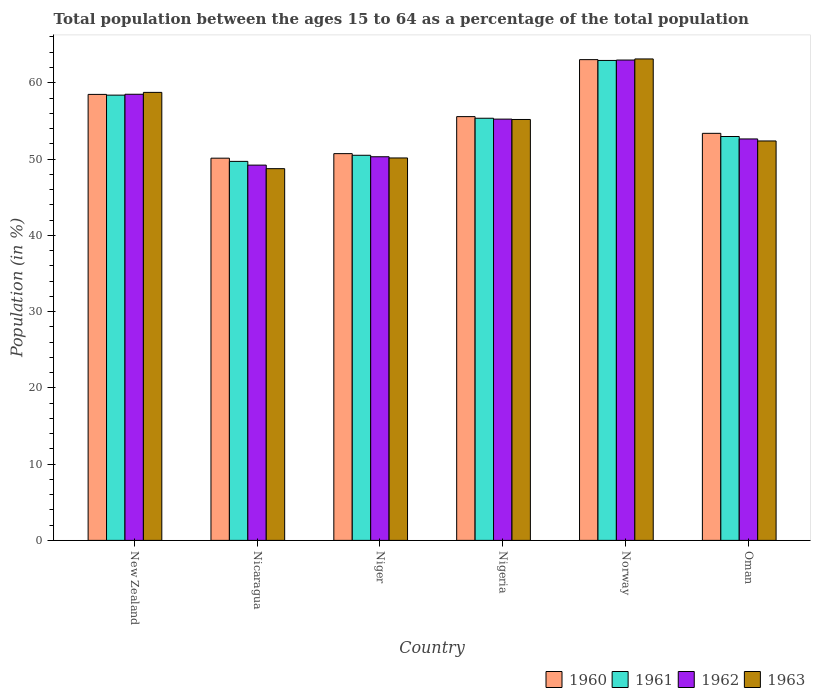How many different coloured bars are there?
Keep it short and to the point. 4. How many groups of bars are there?
Provide a succinct answer. 6. Are the number of bars per tick equal to the number of legend labels?
Your answer should be compact. Yes. How many bars are there on the 3rd tick from the left?
Keep it short and to the point. 4. What is the percentage of the population ages 15 to 64 in 1962 in Norway?
Your answer should be compact. 62.98. Across all countries, what is the maximum percentage of the population ages 15 to 64 in 1961?
Offer a very short reply. 62.92. Across all countries, what is the minimum percentage of the population ages 15 to 64 in 1963?
Provide a succinct answer. 48.74. In which country was the percentage of the population ages 15 to 64 in 1962 minimum?
Ensure brevity in your answer.  Nicaragua. What is the total percentage of the population ages 15 to 64 in 1960 in the graph?
Your answer should be compact. 331.26. What is the difference between the percentage of the population ages 15 to 64 in 1963 in Nicaragua and that in Norway?
Provide a short and direct response. -14.39. What is the difference between the percentage of the population ages 15 to 64 in 1962 in Oman and the percentage of the population ages 15 to 64 in 1960 in Nigeria?
Offer a terse response. -2.93. What is the average percentage of the population ages 15 to 64 in 1962 per country?
Give a very brief answer. 54.81. What is the difference between the percentage of the population ages 15 to 64 of/in 1962 and percentage of the population ages 15 to 64 of/in 1961 in Niger?
Your response must be concise. -0.2. What is the ratio of the percentage of the population ages 15 to 64 in 1961 in Nicaragua to that in Niger?
Offer a very short reply. 0.98. Is the percentage of the population ages 15 to 64 in 1961 in Niger less than that in Oman?
Provide a succinct answer. Yes. Is the difference between the percentage of the population ages 15 to 64 in 1962 in Nicaragua and Norway greater than the difference between the percentage of the population ages 15 to 64 in 1961 in Nicaragua and Norway?
Keep it short and to the point. No. What is the difference between the highest and the second highest percentage of the population ages 15 to 64 in 1962?
Provide a succinct answer. -4.49. What is the difference between the highest and the lowest percentage of the population ages 15 to 64 in 1960?
Offer a terse response. 12.92. What does the 2nd bar from the left in Nigeria represents?
Provide a short and direct response. 1961. What does the 2nd bar from the right in Oman represents?
Your answer should be compact. 1962. Are the values on the major ticks of Y-axis written in scientific E-notation?
Your answer should be very brief. No. Does the graph contain any zero values?
Provide a succinct answer. No. How many legend labels are there?
Your response must be concise. 4. How are the legend labels stacked?
Your answer should be compact. Horizontal. What is the title of the graph?
Provide a short and direct response. Total population between the ages 15 to 64 as a percentage of the total population. Does "2004" appear as one of the legend labels in the graph?
Offer a terse response. No. What is the Population (in %) in 1960 in New Zealand?
Provide a short and direct response. 58.47. What is the Population (in %) of 1961 in New Zealand?
Make the answer very short. 58.38. What is the Population (in %) of 1962 in New Zealand?
Make the answer very short. 58.49. What is the Population (in %) of 1963 in New Zealand?
Give a very brief answer. 58.74. What is the Population (in %) of 1960 in Nicaragua?
Provide a short and direct response. 50.11. What is the Population (in %) of 1961 in Nicaragua?
Ensure brevity in your answer.  49.69. What is the Population (in %) of 1962 in Nicaragua?
Your answer should be very brief. 49.2. What is the Population (in %) of 1963 in Nicaragua?
Keep it short and to the point. 48.74. What is the Population (in %) of 1960 in Niger?
Offer a terse response. 50.71. What is the Population (in %) in 1961 in Niger?
Your answer should be compact. 50.49. What is the Population (in %) of 1962 in Niger?
Offer a very short reply. 50.3. What is the Population (in %) in 1963 in Niger?
Keep it short and to the point. 50.14. What is the Population (in %) of 1960 in Nigeria?
Offer a very short reply. 55.56. What is the Population (in %) of 1961 in Nigeria?
Provide a succinct answer. 55.35. What is the Population (in %) in 1962 in Nigeria?
Keep it short and to the point. 55.23. What is the Population (in %) in 1963 in Nigeria?
Your answer should be compact. 55.19. What is the Population (in %) in 1960 in Norway?
Keep it short and to the point. 63.03. What is the Population (in %) in 1961 in Norway?
Provide a short and direct response. 62.92. What is the Population (in %) in 1962 in Norway?
Provide a short and direct response. 62.98. What is the Population (in %) of 1963 in Norway?
Make the answer very short. 63.12. What is the Population (in %) of 1960 in Oman?
Provide a short and direct response. 53.37. What is the Population (in %) of 1961 in Oman?
Your answer should be compact. 52.95. What is the Population (in %) in 1962 in Oman?
Make the answer very short. 52.63. What is the Population (in %) of 1963 in Oman?
Keep it short and to the point. 52.37. Across all countries, what is the maximum Population (in %) of 1960?
Provide a short and direct response. 63.03. Across all countries, what is the maximum Population (in %) in 1961?
Your answer should be very brief. 62.92. Across all countries, what is the maximum Population (in %) of 1962?
Your response must be concise. 62.98. Across all countries, what is the maximum Population (in %) in 1963?
Your response must be concise. 63.12. Across all countries, what is the minimum Population (in %) in 1960?
Offer a terse response. 50.11. Across all countries, what is the minimum Population (in %) of 1961?
Make the answer very short. 49.69. Across all countries, what is the minimum Population (in %) of 1962?
Offer a very short reply. 49.2. Across all countries, what is the minimum Population (in %) in 1963?
Keep it short and to the point. 48.74. What is the total Population (in %) of 1960 in the graph?
Your answer should be very brief. 331.26. What is the total Population (in %) of 1961 in the graph?
Your answer should be very brief. 329.79. What is the total Population (in %) in 1962 in the graph?
Your answer should be very brief. 328.84. What is the total Population (in %) of 1963 in the graph?
Provide a succinct answer. 328.3. What is the difference between the Population (in %) of 1960 in New Zealand and that in Nicaragua?
Your response must be concise. 8.36. What is the difference between the Population (in %) of 1961 in New Zealand and that in Nicaragua?
Your answer should be compact. 8.69. What is the difference between the Population (in %) of 1962 in New Zealand and that in Nicaragua?
Your answer should be compact. 9.29. What is the difference between the Population (in %) in 1963 in New Zealand and that in Nicaragua?
Ensure brevity in your answer.  10. What is the difference between the Population (in %) of 1960 in New Zealand and that in Niger?
Provide a short and direct response. 7.77. What is the difference between the Population (in %) in 1961 in New Zealand and that in Niger?
Provide a succinct answer. 7.88. What is the difference between the Population (in %) of 1962 in New Zealand and that in Niger?
Ensure brevity in your answer.  8.2. What is the difference between the Population (in %) of 1963 in New Zealand and that in Niger?
Make the answer very short. 8.6. What is the difference between the Population (in %) in 1960 in New Zealand and that in Nigeria?
Keep it short and to the point. 2.91. What is the difference between the Population (in %) in 1961 in New Zealand and that in Nigeria?
Your answer should be very brief. 3.03. What is the difference between the Population (in %) of 1962 in New Zealand and that in Nigeria?
Offer a very short reply. 3.26. What is the difference between the Population (in %) of 1963 in New Zealand and that in Nigeria?
Provide a short and direct response. 3.55. What is the difference between the Population (in %) in 1960 in New Zealand and that in Norway?
Keep it short and to the point. -4.56. What is the difference between the Population (in %) of 1961 in New Zealand and that in Norway?
Your answer should be compact. -4.55. What is the difference between the Population (in %) in 1962 in New Zealand and that in Norway?
Ensure brevity in your answer.  -4.49. What is the difference between the Population (in %) of 1963 in New Zealand and that in Norway?
Keep it short and to the point. -4.38. What is the difference between the Population (in %) in 1960 in New Zealand and that in Oman?
Your answer should be compact. 5.11. What is the difference between the Population (in %) in 1961 in New Zealand and that in Oman?
Your response must be concise. 5.42. What is the difference between the Population (in %) in 1962 in New Zealand and that in Oman?
Provide a short and direct response. 5.86. What is the difference between the Population (in %) in 1963 in New Zealand and that in Oman?
Your answer should be very brief. 6.37. What is the difference between the Population (in %) of 1960 in Nicaragua and that in Niger?
Give a very brief answer. -0.6. What is the difference between the Population (in %) in 1961 in Nicaragua and that in Niger?
Give a very brief answer. -0.8. What is the difference between the Population (in %) in 1962 in Nicaragua and that in Niger?
Make the answer very short. -1.1. What is the difference between the Population (in %) in 1963 in Nicaragua and that in Niger?
Provide a short and direct response. -1.41. What is the difference between the Population (in %) in 1960 in Nicaragua and that in Nigeria?
Make the answer very short. -5.45. What is the difference between the Population (in %) in 1961 in Nicaragua and that in Nigeria?
Give a very brief answer. -5.66. What is the difference between the Population (in %) of 1962 in Nicaragua and that in Nigeria?
Offer a terse response. -6.03. What is the difference between the Population (in %) in 1963 in Nicaragua and that in Nigeria?
Offer a very short reply. -6.45. What is the difference between the Population (in %) of 1960 in Nicaragua and that in Norway?
Offer a terse response. -12.92. What is the difference between the Population (in %) in 1961 in Nicaragua and that in Norway?
Make the answer very short. -13.23. What is the difference between the Population (in %) in 1962 in Nicaragua and that in Norway?
Your answer should be very brief. -13.78. What is the difference between the Population (in %) in 1963 in Nicaragua and that in Norway?
Your answer should be very brief. -14.39. What is the difference between the Population (in %) of 1960 in Nicaragua and that in Oman?
Your answer should be compact. -3.26. What is the difference between the Population (in %) of 1961 in Nicaragua and that in Oman?
Offer a terse response. -3.26. What is the difference between the Population (in %) of 1962 in Nicaragua and that in Oman?
Make the answer very short. -3.43. What is the difference between the Population (in %) in 1963 in Nicaragua and that in Oman?
Offer a very short reply. -3.63. What is the difference between the Population (in %) of 1960 in Niger and that in Nigeria?
Your answer should be compact. -4.85. What is the difference between the Population (in %) in 1961 in Niger and that in Nigeria?
Keep it short and to the point. -4.85. What is the difference between the Population (in %) of 1962 in Niger and that in Nigeria?
Provide a succinct answer. -4.93. What is the difference between the Population (in %) in 1963 in Niger and that in Nigeria?
Your response must be concise. -5.05. What is the difference between the Population (in %) in 1960 in Niger and that in Norway?
Your answer should be compact. -12.32. What is the difference between the Population (in %) in 1961 in Niger and that in Norway?
Make the answer very short. -12.43. What is the difference between the Population (in %) in 1962 in Niger and that in Norway?
Provide a short and direct response. -12.68. What is the difference between the Population (in %) of 1963 in Niger and that in Norway?
Keep it short and to the point. -12.98. What is the difference between the Population (in %) of 1960 in Niger and that in Oman?
Give a very brief answer. -2.66. What is the difference between the Population (in %) of 1961 in Niger and that in Oman?
Provide a succinct answer. -2.46. What is the difference between the Population (in %) in 1962 in Niger and that in Oman?
Offer a very short reply. -2.34. What is the difference between the Population (in %) of 1963 in Niger and that in Oman?
Make the answer very short. -2.23. What is the difference between the Population (in %) in 1960 in Nigeria and that in Norway?
Your response must be concise. -7.47. What is the difference between the Population (in %) in 1961 in Nigeria and that in Norway?
Offer a very short reply. -7.58. What is the difference between the Population (in %) of 1962 in Nigeria and that in Norway?
Your answer should be very brief. -7.75. What is the difference between the Population (in %) of 1963 in Nigeria and that in Norway?
Your answer should be very brief. -7.94. What is the difference between the Population (in %) of 1960 in Nigeria and that in Oman?
Ensure brevity in your answer.  2.19. What is the difference between the Population (in %) in 1961 in Nigeria and that in Oman?
Your response must be concise. 2.39. What is the difference between the Population (in %) in 1962 in Nigeria and that in Oman?
Offer a terse response. 2.6. What is the difference between the Population (in %) in 1963 in Nigeria and that in Oman?
Keep it short and to the point. 2.82. What is the difference between the Population (in %) in 1960 in Norway and that in Oman?
Your answer should be compact. 9.66. What is the difference between the Population (in %) of 1961 in Norway and that in Oman?
Offer a terse response. 9.97. What is the difference between the Population (in %) of 1962 in Norway and that in Oman?
Your response must be concise. 10.34. What is the difference between the Population (in %) of 1963 in Norway and that in Oman?
Offer a very short reply. 10.75. What is the difference between the Population (in %) in 1960 in New Zealand and the Population (in %) in 1961 in Nicaragua?
Offer a very short reply. 8.78. What is the difference between the Population (in %) in 1960 in New Zealand and the Population (in %) in 1962 in Nicaragua?
Your answer should be compact. 9.27. What is the difference between the Population (in %) of 1960 in New Zealand and the Population (in %) of 1963 in Nicaragua?
Ensure brevity in your answer.  9.74. What is the difference between the Population (in %) in 1961 in New Zealand and the Population (in %) in 1962 in Nicaragua?
Your answer should be compact. 9.18. What is the difference between the Population (in %) of 1961 in New Zealand and the Population (in %) of 1963 in Nicaragua?
Provide a succinct answer. 9.64. What is the difference between the Population (in %) in 1962 in New Zealand and the Population (in %) in 1963 in Nicaragua?
Provide a short and direct response. 9.76. What is the difference between the Population (in %) of 1960 in New Zealand and the Population (in %) of 1961 in Niger?
Give a very brief answer. 7.98. What is the difference between the Population (in %) in 1960 in New Zealand and the Population (in %) in 1962 in Niger?
Offer a very short reply. 8.18. What is the difference between the Population (in %) of 1960 in New Zealand and the Population (in %) of 1963 in Niger?
Make the answer very short. 8.33. What is the difference between the Population (in %) of 1961 in New Zealand and the Population (in %) of 1962 in Niger?
Keep it short and to the point. 8.08. What is the difference between the Population (in %) in 1961 in New Zealand and the Population (in %) in 1963 in Niger?
Your answer should be very brief. 8.24. What is the difference between the Population (in %) in 1962 in New Zealand and the Population (in %) in 1963 in Niger?
Your answer should be very brief. 8.35. What is the difference between the Population (in %) of 1960 in New Zealand and the Population (in %) of 1961 in Nigeria?
Your answer should be compact. 3.13. What is the difference between the Population (in %) in 1960 in New Zealand and the Population (in %) in 1962 in Nigeria?
Your answer should be very brief. 3.24. What is the difference between the Population (in %) of 1960 in New Zealand and the Population (in %) of 1963 in Nigeria?
Offer a very short reply. 3.29. What is the difference between the Population (in %) in 1961 in New Zealand and the Population (in %) in 1962 in Nigeria?
Give a very brief answer. 3.15. What is the difference between the Population (in %) in 1961 in New Zealand and the Population (in %) in 1963 in Nigeria?
Your response must be concise. 3.19. What is the difference between the Population (in %) of 1962 in New Zealand and the Population (in %) of 1963 in Nigeria?
Keep it short and to the point. 3.31. What is the difference between the Population (in %) in 1960 in New Zealand and the Population (in %) in 1961 in Norway?
Offer a very short reply. -4.45. What is the difference between the Population (in %) of 1960 in New Zealand and the Population (in %) of 1962 in Norway?
Your response must be concise. -4.5. What is the difference between the Population (in %) of 1960 in New Zealand and the Population (in %) of 1963 in Norway?
Your answer should be very brief. -4.65. What is the difference between the Population (in %) of 1961 in New Zealand and the Population (in %) of 1962 in Norway?
Ensure brevity in your answer.  -4.6. What is the difference between the Population (in %) of 1961 in New Zealand and the Population (in %) of 1963 in Norway?
Your answer should be compact. -4.74. What is the difference between the Population (in %) of 1962 in New Zealand and the Population (in %) of 1963 in Norway?
Give a very brief answer. -4.63. What is the difference between the Population (in %) in 1960 in New Zealand and the Population (in %) in 1961 in Oman?
Your response must be concise. 5.52. What is the difference between the Population (in %) of 1960 in New Zealand and the Population (in %) of 1962 in Oman?
Your answer should be very brief. 5.84. What is the difference between the Population (in %) of 1960 in New Zealand and the Population (in %) of 1963 in Oman?
Keep it short and to the point. 6.11. What is the difference between the Population (in %) in 1961 in New Zealand and the Population (in %) in 1962 in Oman?
Provide a short and direct response. 5.74. What is the difference between the Population (in %) of 1961 in New Zealand and the Population (in %) of 1963 in Oman?
Offer a very short reply. 6.01. What is the difference between the Population (in %) of 1962 in New Zealand and the Population (in %) of 1963 in Oman?
Your response must be concise. 6.12. What is the difference between the Population (in %) in 1960 in Nicaragua and the Population (in %) in 1961 in Niger?
Your answer should be very brief. -0.38. What is the difference between the Population (in %) of 1960 in Nicaragua and the Population (in %) of 1962 in Niger?
Your answer should be compact. -0.19. What is the difference between the Population (in %) in 1960 in Nicaragua and the Population (in %) in 1963 in Niger?
Keep it short and to the point. -0.03. What is the difference between the Population (in %) of 1961 in Nicaragua and the Population (in %) of 1962 in Niger?
Provide a succinct answer. -0.61. What is the difference between the Population (in %) in 1961 in Nicaragua and the Population (in %) in 1963 in Niger?
Offer a terse response. -0.45. What is the difference between the Population (in %) in 1962 in Nicaragua and the Population (in %) in 1963 in Niger?
Make the answer very short. -0.94. What is the difference between the Population (in %) of 1960 in Nicaragua and the Population (in %) of 1961 in Nigeria?
Ensure brevity in your answer.  -5.23. What is the difference between the Population (in %) in 1960 in Nicaragua and the Population (in %) in 1962 in Nigeria?
Keep it short and to the point. -5.12. What is the difference between the Population (in %) in 1960 in Nicaragua and the Population (in %) in 1963 in Nigeria?
Your answer should be compact. -5.07. What is the difference between the Population (in %) of 1961 in Nicaragua and the Population (in %) of 1962 in Nigeria?
Ensure brevity in your answer.  -5.54. What is the difference between the Population (in %) in 1961 in Nicaragua and the Population (in %) in 1963 in Nigeria?
Offer a very short reply. -5.5. What is the difference between the Population (in %) of 1962 in Nicaragua and the Population (in %) of 1963 in Nigeria?
Provide a succinct answer. -5.98. What is the difference between the Population (in %) in 1960 in Nicaragua and the Population (in %) in 1961 in Norway?
Offer a terse response. -12.81. What is the difference between the Population (in %) of 1960 in Nicaragua and the Population (in %) of 1962 in Norway?
Make the answer very short. -12.87. What is the difference between the Population (in %) in 1960 in Nicaragua and the Population (in %) in 1963 in Norway?
Offer a terse response. -13.01. What is the difference between the Population (in %) of 1961 in Nicaragua and the Population (in %) of 1962 in Norway?
Keep it short and to the point. -13.29. What is the difference between the Population (in %) of 1961 in Nicaragua and the Population (in %) of 1963 in Norway?
Your answer should be compact. -13.43. What is the difference between the Population (in %) in 1962 in Nicaragua and the Population (in %) in 1963 in Norway?
Provide a short and direct response. -13.92. What is the difference between the Population (in %) of 1960 in Nicaragua and the Population (in %) of 1961 in Oman?
Provide a succinct answer. -2.84. What is the difference between the Population (in %) of 1960 in Nicaragua and the Population (in %) of 1962 in Oman?
Provide a succinct answer. -2.52. What is the difference between the Population (in %) in 1960 in Nicaragua and the Population (in %) in 1963 in Oman?
Give a very brief answer. -2.26. What is the difference between the Population (in %) of 1961 in Nicaragua and the Population (in %) of 1962 in Oman?
Make the answer very short. -2.94. What is the difference between the Population (in %) of 1961 in Nicaragua and the Population (in %) of 1963 in Oman?
Offer a very short reply. -2.68. What is the difference between the Population (in %) in 1962 in Nicaragua and the Population (in %) in 1963 in Oman?
Give a very brief answer. -3.17. What is the difference between the Population (in %) in 1960 in Niger and the Population (in %) in 1961 in Nigeria?
Provide a short and direct response. -4.64. What is the difference between the Population (in %) in 1960 in Niger and the Population (in %) in 1962 in Nigeria?
Provide a succinct answer. -4.52. What is the difference between the Population (in %) of 1960 in Niger and the Population (in %) of 1963 in Nigeria?
Make the answer very short. -4.48. What is the difference between the Population (in %) of 1961 in Niger and the Population (in %) of 1962 in Nigeria?
Keep it short and to the point. -4.74. What is the difference between the Population (in %) of 1961 in Niger and the Population (in %) of 1963 in Nigeria?
Keep it short and to the point. -4.69. What is the difference between the Population (in %) in 1962 in Niger and the Population (in %) in 1963 in Nigeria?
Provide a short and direct response. -4.89. What is the difference between the Population (in %) of 1960 in Niger and the Population (in %) of 1961 in Norway?
Your response must be concise. -12.22. What is the difference between the Population (in %) in 1960 in Niger and the Population (in %) in 1962 in Norway?
Your response must be concise. -12.27. What is the difference between the Population (in %) of 1960 in Niger and the Population (in %) of 1963 in Norway?
Offer a terse response. -12.41. What is the difference between the Population (in %) of 1961 in Niger and the Population (in %) of 1962 in Norway?
Offer a terse response. -12.49. What is the difference between the Population (in %) of 1961 in Niger and the Population (in %) of 1963 in Norway?
Offer a very short reply. -12.63. What is the difference between the Population (in %) of 1962 in Niger and the Population (in %) of 1963 in Norway?
Your answer should be very brief. -12.82. What is the difference between the Population (in %) in 1960 in Niger and the Population (in %) in 1961 in Oman?
Your answer should be compact. -2.25. What is the difference between the Population (in %) in 1960 in Niger and the Population (in %) in 1962 in Oman?
Provide a succinct answer. -1.93. What is the difference between the Population (in %) of 1960 in Niger and the Population (in %) of 1963 in Oman?
Provide a succinct answer. -1.66. What is the difference between the Population (in %) of 1961 in Niger and the Population (in %) of 1962 in Oman?
Keep it short and to the point. -2.14. What is the difference between the Population (in %) of 1961 in Niger and the Population (in %) of 1963 in Oman?
Provide a succinct answer. -1.87. What is the difference between the Population (in %) of 1962 in Niger and the Population (in %) of 1963 in Oman?
Give a very brief answer. -2.07. What is the difference between the Population (in %) of 1960 in Nigeria and the Population (in %) of 1961 in Norway?
Provide a succinct answer. -7.36. What is the difference between the Population (in %) of 1960 in Nigeria and the Population (in %) of 1962 in Norway?
Your answer should be very brief. -7.42. What is the difference between the Population (in %) in 1960 in Nigeria and the Population (in %) in 1963 in Norway?
Offer a very short reply. -7.56. What is the difference between the Population (in %) of 1961 in Nigeria and the Population (in %) of 1962 in Norway?
Offer a very short reply. -7.63. What is the difference between the Population (in %) in 1961 in Nigeria and the Population (in %) in 1963 in Norway?
Give a very brief answer. -7.78. What is the difference between the Population (in %) in 1962 in Nigeria and the Population (in %) in 1963 in Norway?
Provide a succinct answer. -7.89. What is the difference between the Population (in %) of 1960 in Nigeria and the Population (in %) of 1961 in Oman?
Your answer should be very brief. 2.61. What is the difference between the Population (in %) in 1960 in Nigeria and the Population (in %) in 1962 in Oman?
Your answer should be compact. 2.93. What is the difference between the Population (in %) of 1960 in Nigeria and the Population (in %) of 1963 in Oman?
Provide a short and direct response. 3.19. What is the difference between the Population (in %) of 1961 in Nigeria and the Population (in %) of 1962 in Oman?
Provide a short and direct response. 2.71. What is the difference between the Population (in %) in 1961 in Nigeria and the Population (in %) in 1963 in Oman?
Keep it short and to the point. 2.98. What is the difference between the Population (in %) of 1962 in Nigeria and the Population (in %) of 1963 in Oman?
Provide a short and direct response. 2.86. What is the difference between the Population (in %) in 1960 in Norway and the Population (in %) in 1961 in Oman?
Offer a terse response. 10.08. What is the difference between the Population (in %) in 1960 in Norway and the Population (in %) in 1962 in Oman?
Make the answer very short. 10.4. What is the difference between the Population (in %) in 1960 in Norway and the Population (in %) in 1963 in Oman?
Your answer should be compact. 10.66. What is the difference between the Population (in %) in 1961 in Norway and the Population (in %) in 1962 in Oman?
Provide a succinct answer. 10.29. What is the difference between the Population (in %) of 1961 in Norway and the Population (in %) of 1963 in Oman?
Keep it short and to the point. 10.56. What is the difference between the Population (in %) of 1962 in Norway and the Population (in %) of 1963 in Oman?
Provide a succinct answer. 10.61. What is the average Population (in %) in 1960 per country?
Make the answer very short. 55.21. What is the average Population (in %) of 1961 per country?
Give a very brief answer. 54.96. What is the average Population (in %) in 1962 per country?
Provide a short and direct response. 54.81. What is the average Population (in %) in 1963 per country?
Keep it short and to the point. 54.72. What is the difference between the Population (in %) of 1960 and Population (in %) of 1961 in New Zealand?
Your response must be concise. 0.1. What is the difference between the Population (in %) in 1960 and Population (in %) in 1962 in New Zealand?
Ensure brevity in your answer.  -0.02. What is the difference between the Population (in %) in 1960 and Population (in %) in 1963 in New Zealand?
Provide a short and direct response. -0.27. What is the difference between the Population (in %) of 1961 and Population (in %) of 1962 in New Zealand?
Provide a succinct answer. -0.12. What is the difference between the Population (in %) in 1961 and Population (in %) in 1963 in New Zealand?
Offer a terse response. -0.36. What is the difference between the Population (in %) in 1962 and Population (in %) in 1963 in New Zealand?
Make the answer very short. -0.25. What is the difference between the Population (in %) of 1960 and Population (in %) of 1961 in Nicaragua?
Your answer should be very brief. 0.42. What is the difference between the Population (in %) in 1960 and Population (in %) in 1962 in Nicaragua?
Offer a terse response. 0.91. What is the difference between the Population (in %) of 1960 and Population (in %) of 1963 in Nicaragua?
Make the answer very short. 1.38. What is the difference between the Population (in %) of 1961 and Population (in %) of 1962 in Nicaragua?
Provide a succinct answer. 0.49. What is the difference between the Population (in %) of 1961 and Population (in %) of 1963 in Nicaragua?
Offer a very short reply. 0.96. What is the difference between the Population (in %) in 1962 and Population (in %) in 1963 in Nicaragua?
Your response must be concise. 0.47. What is the difference between the Population (in %) of 1960 and Population (in %) of 1961 in Niger?
Your answer should be very brief. 0.21. What is the difference between the Population (in %) of 1960 and Population (in %) of 1962 in Niger?
Offer a very short reply. 0.41. What is the difference between the Population (in %) in 1960 and Population (in %) in 1963 in Niger?
Make the answer very short. 0.57. What is the difference between the Population (in %) in 1961 and Population (in %) in 1962 in Niger?
Your answer should be very brief. 0.2. What is the difference between the Population (in %) in 1961 and Population (in %) in 1963 in Niger?
Your response must be concise. 0.35. What is the difference between the Population (in %) of 1962 and Population (in %) of 1963 in Niger?
Give a very brief answer. 0.16. What is the difference between the Population (in %) of 1960 and Population (in %) of 1961 in Nigeria?
Give a very brief answer. 0.21. What is the difference between the Population (in %) of 1960 and Population (in %) of 1962 in Nigeria?
Give a very brief answer. 0.33. What is the difference between the Population (in %) in 1960 and Population (in %) in 1963 in Nigeria?
Give a very brief answer. 0.37. What is the difference between the Population (in %) of 1961 and Population (in %) of 1962 in Nigeria?
Your response must be concise. 0.11. What is the difference between the Population (in %) of 1961 and Population (in %) of 1963 in Nigeria?
Your answer should be very brief. 0.16. What is the difference between the Population (in %) of 1962 and Population (in %) of 1963 in Nigeria?
Your answer should be very brief. 0.05. What is the difference between the Population (in %) of 1960 and Population (in %) of 1961 in Norway?
Your answer should be compact. 0.11. What is the difference between the Population (in %) in 1960 and Population (in %) in 1962 in Norway?
Ensure brevity in your answer.  0.05. What is the difference between the Population (in %) of 1960 and Population (in %) of 1963 in Norway?
Keep it short and to the point. -0.09. What is the difference between the Population (in %) in 1961 and Population (in %) in 1962 in Norway?
Offer a very short reply. -0.05. What is the difference between the Population (in %) of 1961 and Population (in %) of 1963 in Norway?
Make the answer very short. -0.2. What is the difference between the Population (in %) in 1962 and Population (in %) in 1963 in Norway?
Keep it short and to the point. -0.14. What is the difference between the Population (in %) of 1960 and Population (in %) of 1961 in Oman?
Offer a terse response. 0.41. What is the difference between the Population (in %) in 1960 and Population (in %) in 1962 in Oman?
Keep it short and to the point. 0.73. What is the difference between the Population (in %) of 1961 and Population (in %) of 1962 in Oman?
Offer a very short reply. 0.32. What is the difference between the Population (in %) in 1961 and Population (in %) in 1963 in Oman?
Your response must be concise. 0.59. What is the difference between the Population (in %) in 1962 and Population (in %) in 1963 in Oman?
Offer a terse response. 0.27. What is the ratio of the Population (in %) in 1960 in New Zealand to that in Nicaragua?
Provide a succinct answer. 1.17. What is the ratio of the Population (in %) of 1961 in New Zealand to that in Nicaragua?
Give a very brief answer. 1.17. What is the ratio of the Population (in %) in 1962 in New Zealand to that in Nicaragua?
Your response must be concise. 1.19. What is the ratio of the Population (in %) in 1963 in New Zealand to that in Nicaragua?
Your answer should be very brief. 1.21. What is the ratio of the Population (in %) of 1960 in New Zealand to that in Niger?
Keep it short and to the point. 1.15. What is the ratio of the Population (in %) in 1961 in New Zealand to that in Niger?
Your response must be concise. 1.16. What is the ratio of the Population (in %) in 1962 in New Zealand to that in Niger?
Ensure brevity in your answer.  1.16. What is the ratio of the Population (in %) in 1963 in New Zealand to that in Niger?
Offer a very short reply. 1.17. What is the ratio of the Population (in %) of 1960 in New Zealand to that in Nigeria?
Provide a short and direct response. 1.05. What is the ratio of the Population (in %) of 1961 in New Zealand to that in Nigeria?
Provide a succinct answer. 1.05. What is the ratio of the Population (in %) in 1962 in New Zealand to that in Nigeria?
Provide a succinct answer. 1.06. What is the ratio of the Population (in %) in 1963 in New Zealand to that in Nigeria?
Provide a succinct answer. 1.06. What is the ratio of the Population (in %) of 1960 in New Zealand to that in Norway?
Provide a succinct answer. 0.93. What is the ratio of the Population (in %) of 1961 in New Zealand to that in Norway?
Provide a short and direct response. 0.93. What is the ratio of the Population (in %) of 1962 in New Zealand to that in Norway?
Keep it short and to the point. 0.93. What is the ratio of the Population (in %) in 1963 in New Zealand to that in Norway?
Your answer should be very brief. 0.93. What is the ratio of the Population (in %) of 1960 in New Zealand to that in Oman?
Your answer should be very brief. 1.1. What is the ratio of the Population (in %) of 1961 in New Zealand to that in Oman?
Give a very brief answer. 1.1. What is the ratio of the Population (in %) in 1962 in New Zealand to that in Oman?
Your response must be concise. 1.11. What is the ratio of the Population (in %) of 1963 in New Zealand to that in Oman?
Your answer should be compact. 1.12. What is the ratio of the Population (in %) of 1960 in Nicaragua to that in Niger?
Make the answer very short. 0.99. What is the ratio of the Population (in %) in 1961 in Nicaragua to that in Niger?
Your answer should be compact. 0.98. What is the ratio of the Population (in %) of 1962 in Nicaragua to that in Niger?
Provide a succinct answer. 0.98. What is the ratio of the Population (in %) of 1960 in Nicaragua to that in Nigeria?
Offer a terse response. 0.9. What is the ratio of the Population (in %) of 1961 in Nicaragua to that in Nigeria?
Offer a very short reply. 0.9. What is the ratio of the Population (in %) in 1962 in Nicaragua to that in Nigeria?
Your response must be concise. 0.89. What is the ratio of the Population (in %) of 1963 in Nicaragua to that in Nigeria?
Your answer should be compact. 0.88. What is the ratio of the Population (in %) of 1960 in Nicaragua to that in Norway?
Give a very brief answer. 0.8. What is the ratio of the Population (in %) of 1961 in Nicaragua to that in Norway?
Your answer should be very brief. 0.79. What is the ratio of the Population (in %) in 1962 in Nicaragua to that in Norway?
Offer a very short reply. 0.78. What is the ratio of the Population (in %) in 1963 in Nicaragua to that in Norway?
Ensure brevity in your answer.  0.77. What is the ratio of the Population (in %) in 1960 in Nicaragua to that in Oman?
Make the answer very short. 0.94. What is the ratio of the Population (in %) in 1961 in Nicaragua to that in Oman?
Provide a succinct answer. 0.94. What is the ratio of the Population (in %) of 1962 in Nicaragua to that in Oman?
Provide a succinct answer. 0.93. What is the ratio of the Population (in %) in 1963 in Nicaragua to that in Oman?
Provide a succinct answer. 0.93. What is the ratio of the Population (in %) of 1960 in Niger to that in Nigeria?
Make the answer very short. 0.91. What is the ratio of the Population (in %) of 1961 in Niger to that in Nigeria?
Ensure brevity in your answer.  0.91. What is the ratio of the Population (in %) in 1962 in Niger to that in Nigeria?
Your answer should be very brief. 0.91. What is the ratio of the Population (in %) of 1963 in Niger to that in Nigeria?
Offer a terse response. 0.91. What is the ratio of the Population (in %) of 1960 in Niger to that in Norway?
Provide a short and direct response. 0.8. What is the ratio of the Population (in %) of 1961 in Niger to that in Norway?
Ensure brevity in your answer.  0.8. What is the ratio of the Population (in %) in 1962 in Niger to that in Norway?
Your answer should be very brief. 0.8. What is the ratio of the Population (in %) of 1963 in Niger to that in Norway?
Your answer should be compact. 0.79. What is the ratio of the Population (in %) in 1960 in Niger to that in Oman?
Your response must be concise. 0.95. What is the ratio of the Population (in %) of 1961 in Niger to that in Oman?
Ensure brevity in your answer.  0.95. What is the ratio of the Population (in %) in 1962 in Niger to that in Oman?
Provide a short and direct response. 0.96. What is the ratio of the Population (in %) in 1963 in Niger to that in Oman?
Provide a succinct answer. 0.96. What is the ratio of the Population (in %) of 1960 in Nigeria to that in Norway?
Keep it short and to the point. 0.88. What is the ratio of the Population (in %) of 1961 in Nigeria to that in Norway?
Provide a succinct answer. 0.88. What is the ratio of the Population (in %) of 1962 in Nigeria to that in Norway?
Your answer should be compact. 0.88. What is the ratio of the Population (in %) of 1963 in Nigeria to that in Norway?
Your response must be concise. 0.87. What is the ratio of the Population (in %) in 1960 in Nigeria to that in Oman?
Provide a short and direct response. 1.04. What is the ratio of the Population (in %) in 1961 in Nigeria to that in Oman?
Offer a terse response. 1.05. What is the ratio of the Population (in %) in 1962 in Nigeria to that in Oman?
Make the answer very short. 1.05. What is the ratio of the Population (in %) in 1963 in Nigeria to that in Oman?
Provide a succinct answer. 1.05. What is the ratio of the Population (in %) in 1960 in Norway to that in Oman?
Make the answer very short. 1.18. What is the ratio of the Population (in %) in 1961 in Norway to that in Oman?
Make the answer very short. 1.19. What is the ratio of the Population (in %) in 1962 in Norway to that in Oman?
Offer a terse response. 1.2. What is the ratio of the Population (in %) in 1963 in Norway to that in Oman?
Offer a terse response. 1.21. What is the difference between the highest and the second highest Population (in %) of 1960?
Provide a succinct answer. 4.56. What is the difference between the highest and the second highest Population (in %) of 1961?
Keep it short and to the point. 4.55. What is the difference between the highest and the second highest Population (in %) of 1962?
Provide a short and direct response. 4.49. What is the difference between the highest and the second highest Population (in %) of 1963?
Provide a short and direct response. 4.38. What is the difference between the highest and the lowest Population (in %) of 1960?
Offer a terse response. 12.92. What is the difference between the highest and the lowest Population (in %) of 1961?
Your answer should be very brief. 13.23. What is the difference between the highest and the lowest Population (in %) of 1962?
Your answer should be very brief. 13.78. What is the difference between the highest and the lowest Population (in %) of 1963?
Offer a very short reply. 14.39. 